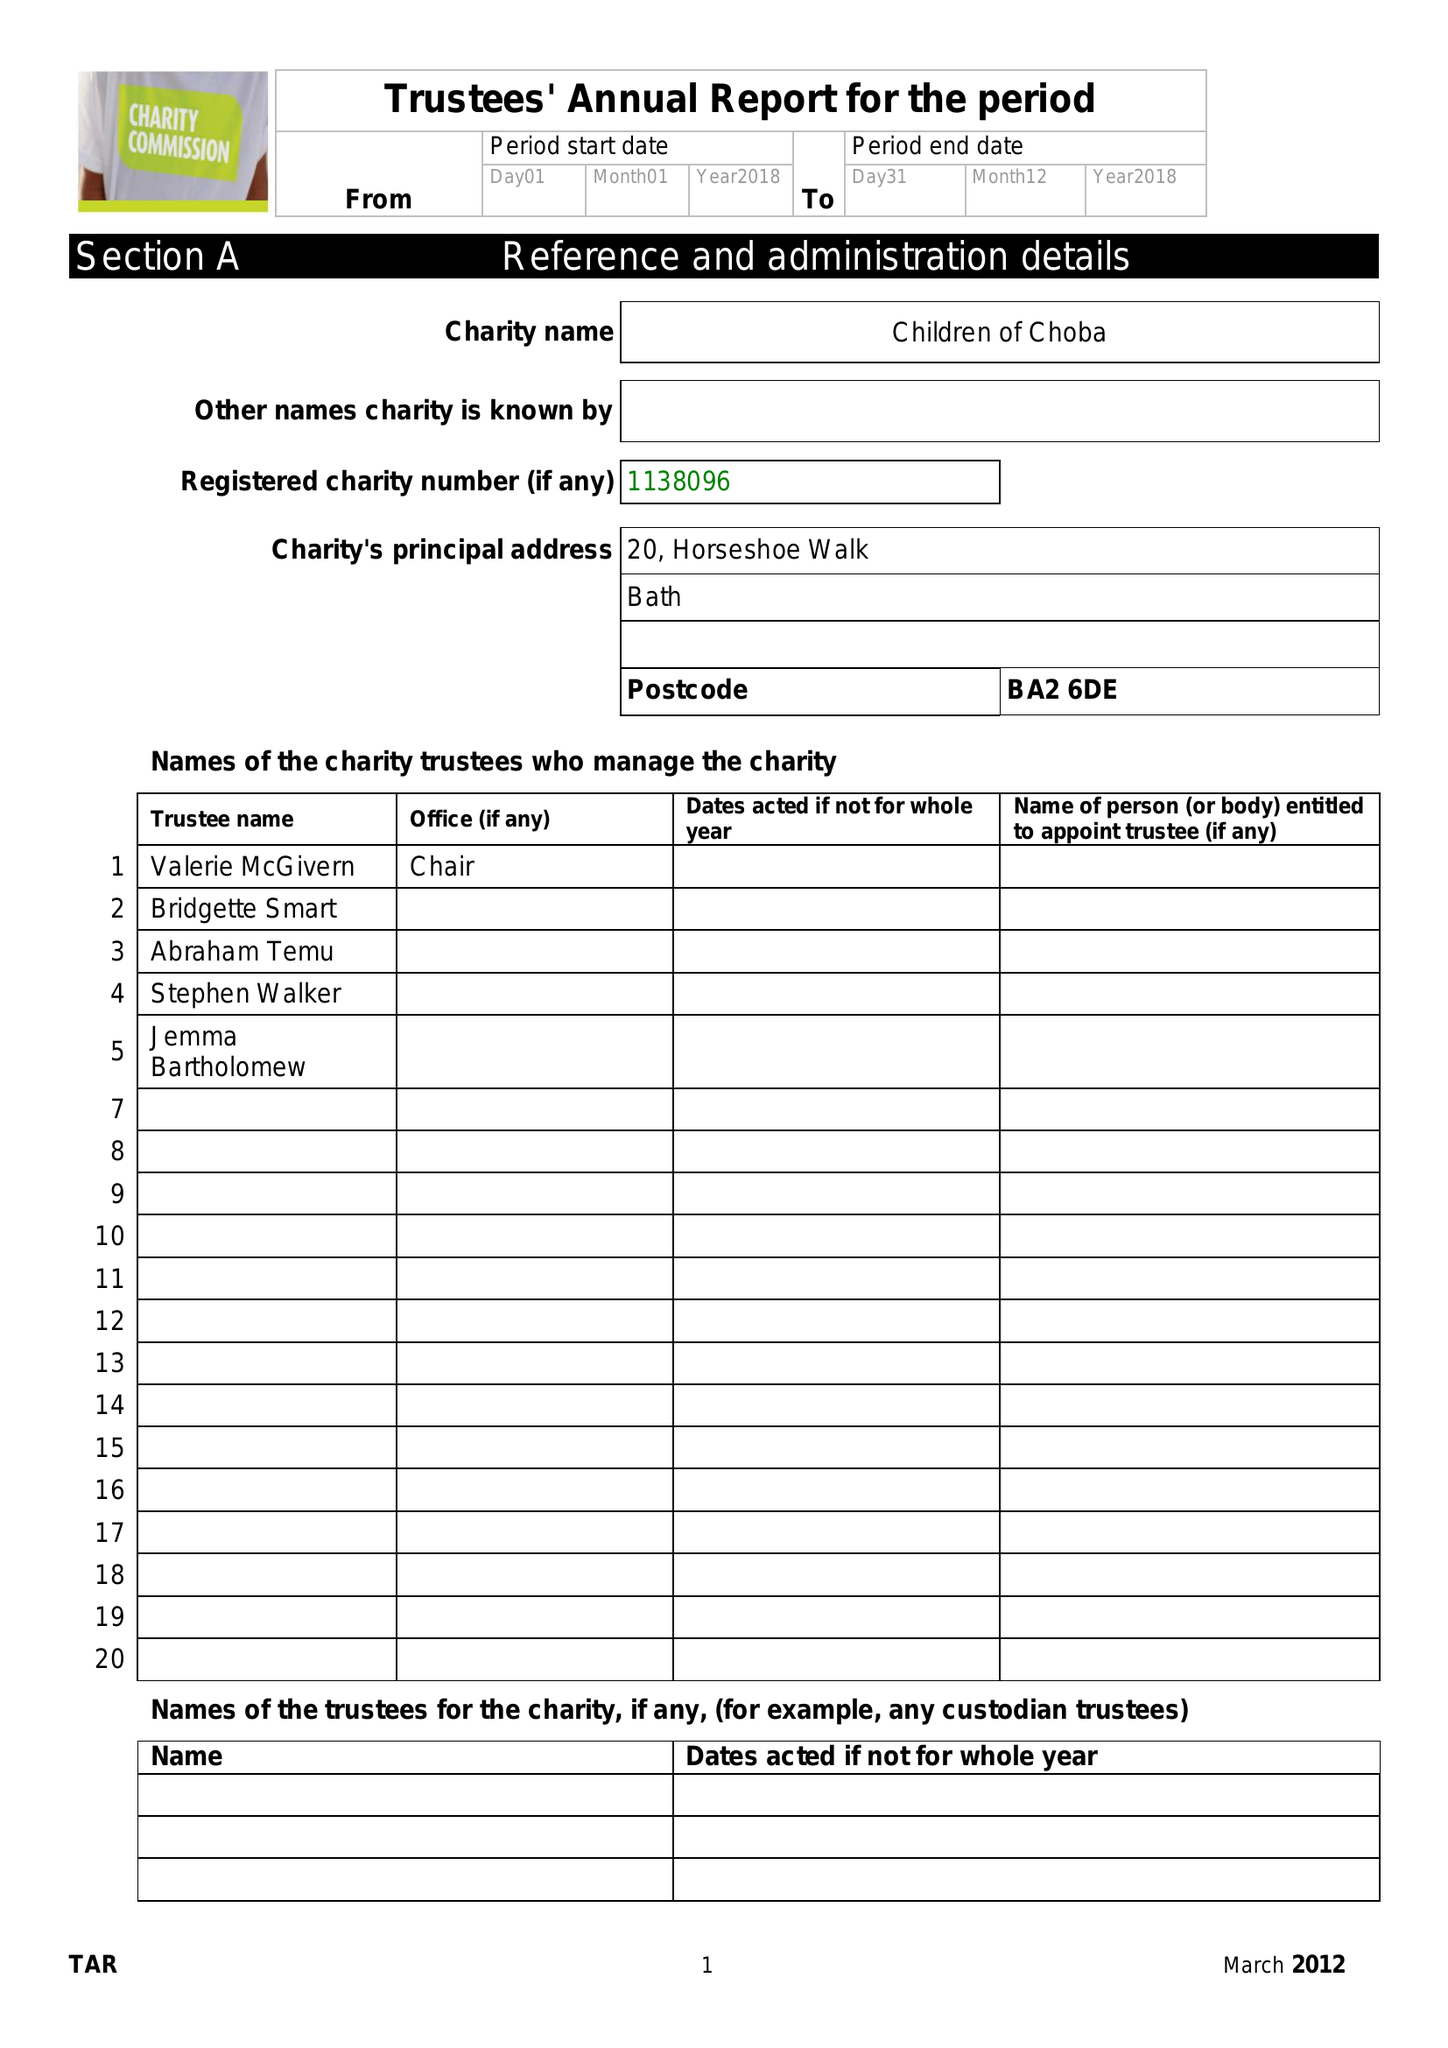What is the value for the income_annually_in_british_pounds?
Answer the question using a single word or phrase. 80899.00 